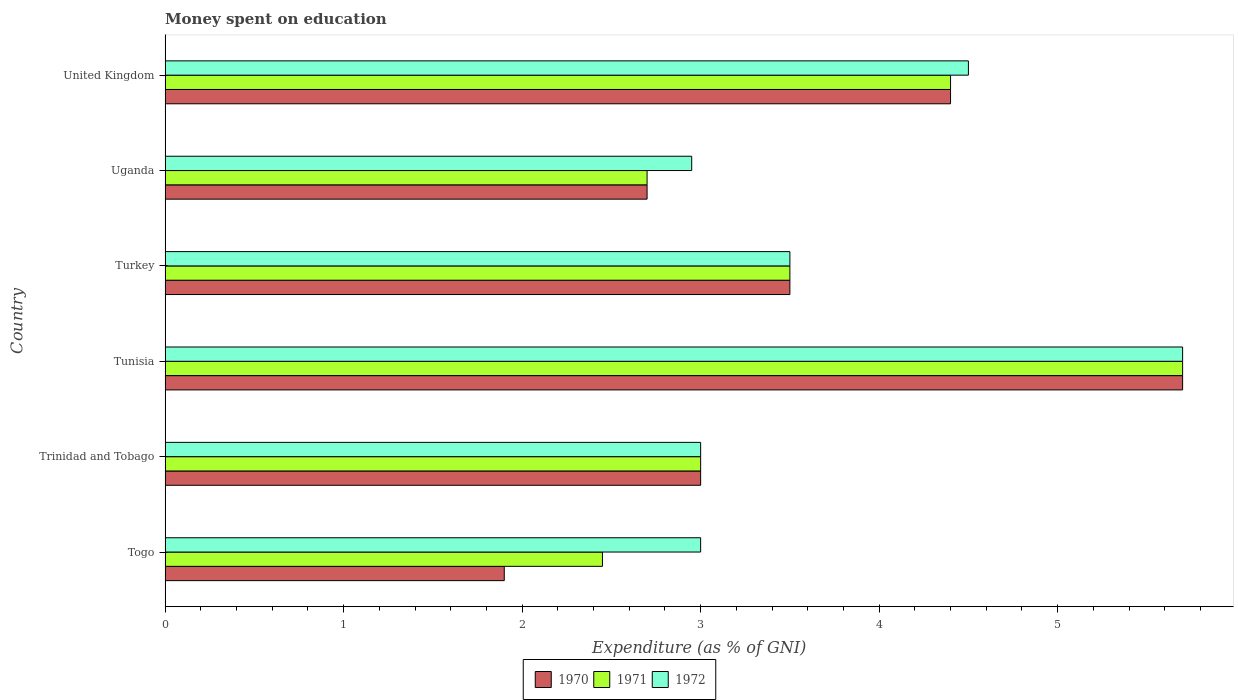How many groups of bars are there?
Offer a terse response. 6. Are the number of bars on each tick of the Y-axis equal?
Offer a terse response. Yes. What is the amount of money spent on education in 1972 in Turkey?
Ensure brevity in your answer.  3.5. Across all countries, what is the minimum amount of money spent on education in 1970?
Give a very brief answer. 1.9. In which country was the amount of money spent on education in 1972 maximum?
Offer a terse response. Tunisia. In which country was the amount of money spent on education in 1970 minimum?
Your answer should be very brief. Togo. What is the total amount of money spent on education in 1971 in the graph?
Your response must be concise. 21.75. What is the difference between the amount of money spent on education in 1971 in Togo and that in Uganda?
Keep it short and to the point. -0.25. What is the difference between the amount of money spent on education in 1970 in Togo and the amount of money spent on education in 1972 in Trinidad and Tobago?
Keep it short and to the point. -1.1. What is the average amount of money spent on education in 1970 per country?
Make the answer very short. 3.53. What is the difference between the amount of money spent on education in 1972 and amount of money spent on education in 1970 in Trinidad and Tobago?
Make the answer very short. 0. In how many countries, is the amount of money spent on education in 1971 greater than 2.4 %?
Provide a short and direct response. 6. What is the ratio of the amount of money spent on education in 1970 in Turkey to that in Uganda?
Provide a succinct answer. 1.3. Is the difference between the amount of money spent on education in 1972 in Tunisia and Turkey greater than the difference between the amount of money spent on education in 1970 in Tunisia and Turkey?
Offer a very short reply. No. What is the difference between the highest and the second highest amount of money spent on education in 1972?
Give a very brief answer. 1.2. What is the difference between the highest and the lowest amount of money spent on education in 1970?
Your response must be concise. 3.8. Is the sum of the amount of money spent on education in 1972 in Togo and United Kingdom greater than the maximum amount of money spent on education in 1971 across all countries?
Offer a terse response. Yes. What does the 3rd bar from the top in Tunisia represents?
Provide a short and direct response. 1970. Are all the bars in the graph horizontal?
Provide a short and direct response. Yes. How many countries are there in the graph?
Provide a short and direct response. 6. Are the values on the major ticks of X-axis written in scientific E-notation?
Your answer should be compact. No. Does the graph contain grids?
Your answer should be compact. No. Where does the legend appear in the graph?
Offer a very short reply. Bottom center. How are the legend labels stacked?
Ensure brevity in your answer.  Horizontal. What is the title of the graph?
Your answer should be very brief. Money spent on education. What is the label or title of the X-axis?
Your response must be concise. Expenditure (as % of GNI). What is the Expenditure (as % of GNI) in 1970 in Togo?
Provide a short and direct response. 1.9. What is the Expenditure (as % of GNI) in 1971 in Togo?
Make the answer very short. 2.45. What is the Expenditure (as % of GNI) of 1972 in Togo?
Provide a succinct answer. 3. What is the Expenditure (as % of GNI) of 1970 in Trinidad and Tobago?
Your response must be concise. 3. What is the Expenditure (as % of GNI) in 1971 in Trinidad and Tobago?
Give a very brief answer. 3. What is the Expenditure (as % of GNI) of 1970 in Tunisia?
Offer a terse response. 5.7. What is the Expenditure (as % of GNI) of 1970 in Turkey?
Provide a succinct answer. 3.5. What is the Expenditure (as % of GNI) in 1972 in Turkey?
Give a very brief answer. 3.5. What is the Expenditure (as % of GNI) in 1970 in Uganda?
Offer a very short reply. 2.7. What is the Expenditure (as % of GNI) in 1972 in Uganda?
Provide a succinct answer. 2.95. Across all countries, what is the maximum Expenditure (as % of GNI) in 1970?
Offer a terse response. 5.7. Across all countries, what is the maximum Expenditure (as % of GNI) of 1971?
Ensure brevity in your answer.  5.7. Across all countries, what is the maximum Expenditure (as % of GNI) of 1972?
Provide a succinct answer. 5.7. Across all countries, what is the minimum Expenditure (as % of GNI) of 1971?
Your response must be concise. 2.45. Across all countries, what is the minimum Expenditure (as % of GNI) of 1972?
Ensure brevity in your answer.  2.95. What is the total Expenditure (as % of GNI) in 1970 in the graph?
Make the answer very short. 21.2. What is the total Expenditure (as % of GNI) of 1971 in the graph?
Your answer should be compact. 21.75. What is the total Expenditure (as % of GNI) of 1972 in the graph?
Provide a short and direct response. 22.65. What is the difference between the Expenditure (as % of GNI) of 1970 in Togo and that in Trinidad and Tobago?
Give a very brief answer. -1.1. What is the difference between the Expenditure (as % of GNI) in 1971 in Togo and that in Trinidad and Tobago?
Make the answer very short. -0.55. What is the difference between the Expenditure (as % of GNI) in 1972 in Togo and that in Trinidad and Tobago?
Provide a succinct answer. 0. What is the difference between the Expenditure (as % of GNI) of 1970 in Togo and that in Tunisia?
Provide a short and direct response. -3.8. What is the difference between the Expenditure (as % of GNI) in 1971 in Togo and that in Tunisia?
Provide a short and direct response. -3.25. What is the difference between the Expenditure (as % of GNI) in 1972 in Togo and that in Tunisia?
Make the answer very short. -2.7. What is the difference between the Expenditure (as % of GNI) in 1970 in Togo and that in Turkey?
Your answer should be very brief. -1.6. What is the difference between the Expenditure (as % of GNI) of 1971 in Togo and that in Turkey?
Offer a very short reply. -1.05. What is the difference between the Expenditure (as % of GNI) in 1972 in Togo and that in Turkey?
Your answer should be compact. -0.5. What is the difference between the Expenditure (as % of GNI) in 1970 in Togo and that in Uganda?
Your answer should be compact. -0.8. What is the difference between the Expenditure (as % of GNI) in 1971 in Togo and that in Uganda?
Ensure brevity in your answer.  -0.25. What is the difference between the Expenditure (as % of GNI) in 1971 in Togo and that in United Kingdom?
Keep it short and to the point. -1.95. What is the difference between the Expenditure (as % of GNI) of 1971 in Trinidad and Tobago and that in Tunisia?
Keep it short and to the point. -2.7. What is the difference between the Expenditure (as % of GNI) of 1972 in Trinidad and Tobago and that in Tunisia?
Provide a short and direct response. -2.7. What is the difference between the Expenditure (as % of GNI) of 1972 in Trinidad and Tobago and that in Uganda?
Your answer should be compact. 0.05. What is the difference between the Expenditure (as % of GNI) of 1970 in Trinidad and Tobago and that in United Kingdom?
Offer a very short reply. -1.4. What is the difference between the Expenditure (as % of GNI) of 1971 in Trinidad and Tobago and that in United Kingdom?
Offer a terse response. -1.4. What is the difference between the Expenditure (as % of GNI) of 1972 in Trinidad and Tobago and that in United Kingdom?
Your answer should be compact. -1.5. What is the difference between the Expenditure (as % of GNI) in 1970 in Tunisia and that in Turkey?
Offer a very short reply. 2.2. What is the difference between the Expenditure (as % of GNI) of 1971 in Tunisia and that in Uganda?
Give a very brief answer. 3. What is the difference between the Expenditure (as % of GNI) of 1972 in Tunisia and that in Uganda?
Your response must be concise. 2.75. What is the difference between the Expenditure (as % of GNI) in 1971 in Tunisia and that in United Kingdom?
Make the answer very short. 1.3. What is the difference between the Expenditure (as % of GNI) in 1972 in Tunisia and that in United Kingdom?
Provide a short and direct response. 1.2. What is the difference between the Expenditure (as % of GNI) of 1970 in Turkey and that in Uganda?
Provide a short and direct response. 0.8. What is the difference between the Expenditure (as % of GNI) of 1972 in Turkey and that in Uganda?
Your answer should be very brief. 0.55. What is the difference between the Expenditure (as % of GNI) in 1970 in Turkey and that in United Kingdom?
Your answer should be very brief. -0.9. What is the difference between the Expenditure (as % of GNI) in 1971 in Turkey and that in United Kingdom?
Keep it short and to the point. -0.9. What is the difference between the Expenditure (as % of GNI) of 1972 in Turkey and that in United Kingdom?
Make the answer very short. -1. What is the difference between the Expenditure (as % of GNI) in 1972 in Uganda and that in United Kingdom?
Keep it short and to the point. -1.55. What is the difference between the Expenditure (as % of GNI) in 1970 in Togo and the Expenditure (as % of GNI) in 1971 in Trinidad and Tobago?
Your response must be concise. -1.1. What is the difference between the Expenditure (as % of GNI) of 1971 in Togo and the Expenditure (as % of GNI) of 1972 in Trinidad and Tobago?
Offer a very short reply. -0.55. What is the difference between the Expenditure (as % of GNI) of 1970 in Togo and the Expenditure (as % of GNI) of 1971 in Tunisia?
Provide a succinct answer. -3.8. What is the difference between the Expenditure (as % of GNI) of 1970 in Togo and the Expenditure (as % of GNI) of 1972 in Tunisia?
Your answer should be very brief. -3.8. What is the difference between the Expenditure (as % of GNI) in 1971 in Togo and the Expenditure (as % of GNI) in 1972 in Tunisia?
Offer a very short reply. -3.25. What is the difference between the Expenditure (as % of GNI) in 1970 in Togo and the Expenditure (as % of GNI) in 1971 in Turkey?
Your answer should be very brief. -1.6. What is the difference between the Expenditure (as % of GNI) of 1970 in Togo and the Expenditure (as % of GNI) of 1972 in Turkey?
Make the answer very short. -1.6. What is the difference between the Expenditure (as % of GNI) in 1971 in Togo and the Expenditure (as % of GNI) in 1972 in Turkey?
Make the answer very short. -1.05. What is the difference between the Expenditure (as % of GNI) in 1970 in Togo and the Expenditure (as % of GNI) in 1971 in Uganda?
Your answer should be very brief. -0.8. What is the difference between the Expenditure (as % of GNI) in 1970 in Togo and the Expenditure (as % of GNI) in 1972 in Uganda?
Keep it short and to the point. -1.05. What is the difference between the Expenditure (as % of GNI) of 1971 in Togo and the Expenditure (as % of GNI) of 1972 in United Kingdom?
Offer a terse response. -2.05. What is the difference between the Expenditure (as % of GNI) of 1970 in Trinidad and Tobago and the Expenditure (as % of GNI) of 1972 in Tunisia?
Give a very brief answer. -2.7. What is the difference between the Expenditure (as % of GNI) in 1971 in Trinidad and Tobago and the Expenditure (as % of GNI) in 1972 in Tunisia?
Offer a terse response. -2.7. What is the difference between the Expenditure (as % of GNI) in 1970 in Trinidad and Tobago and the Expenditure (as % of GNI) in 1971 in Turkey?
Your response must be concise. -0.5. What is the difference between the Expenditure (as % of GNI) in 1970 in Trinidad and Tobago and the Expenditure (as % of GNI) in 1972 in Turkey?
Your answer should be compact. -0.5. What is the difference between the Expenditure (as % of GNI) of 1970 in Trinidad and Tobago and the Expenditure (as % of GNI) of 1971 in United Kingdom?
Your answer should be very brief. -1.4. What is the difference between the Expenditure (as % of GNI) of 1970 in Trinidad and Tobago and the Expenditure (as % of GNI) of 1972 in United Kingdom?
Ensure brevity in your answer.  -1.5. What is the difference between the Expenditure (as % of GNI) in 1971 in Trinidad and Tobago and the Expenditure (as % of GNI) in 1972 in United Kingdom?
Keep it short and to the point. -1.5. What is the difference between the Expenditure (as % of GNI) in 1970 in Tunisia and the Expenditure (as % of GNI) in 1972 in Turkey?
Make the answer very short. 2.2. What is the difference between the Expenditure (as % of GNI) of 1971 in Tunisia and the Expenditure (as % of GNI) of 1972 in Turkey?
Provide a succinct answer. 2.2. What is the difference between the Expenditure (as % of GNI) of 1970 in Tunisia and the Expenditure (as % of GNI) of 1971 in Uganda?
Provide a succinct answer. 3. What is the difference between the Expenditure (as % of GNI) in 1970 in Tunisia and the Expenditure (as % of GNI) in 1972 in Uganda?
Your answer should be very brief. 2.75. What is the difference between the Expenditure (as % of GNI) of 1971 in Tunisia and the Expenditure (as % of GNI) of 1972 in Uganda?
Make the answer very short. 2.75. What is the difference between the Expenditure (as % of GNI) in 1970 in Tunisia and the Expenditure (as % of GNI) in 1971 in United Kingdom?
Give a very brief answer. 1.3. What is the difference between the Expenditure (as % of GNI) in 1970 in Turkey and the Expenditure (as % of GNI) in 1972 in Uganda?
Offer a terse response. 0.55. What is the difference between the Expenditure (as % of GNI) of 1971 in Turkey and the Expenditure (as % of GNI) of 1972 in Uganda?
Ensure brevity in your answer.  0.55. What is the difference between the Expenditure (as % of GNI) of 1970 in Turkey and the Expenditure (as % of GNI) of 1972 in United Kingdom?
Your answer should be very brief. -1. What is the difference between the Expenditure (as % of GNI) in 1971 in Turkey and the Expenditure (as % of GNI) in 1972 in United Kingdom?
Ensure brevity in your answer.  -1. What is the average Expenditure (as % of GNI) in 1970 per country?
Offer a terse response. 3.53. What is the average Expenditure (as % of GNI) in 1971 per country?
Provide a short and direct response. 3.62. What is the average Expenditure (as % of GNI) in 1972 per country?
Keep it short and to the point. 3.77. What is the difference between the Expenditure (as % of GNI) in 1970 and Expenditure (as % of GNI) in 1971 in Togo?
Offer a terse response. -0.55. What is the difference between the Expenditure (as % of GNI) in 1970 and Expenditure (as % of GNI) in 1972 in Togo?
Make the answer very short. -1.1. What is the difference between the Expenditure (as % of GNI) of 1971 and Expenditure (as % of GNI) of 1972 in Togo?
Your response must be concise. -0.55. What is the difference between the Expenditure (as % of GNI) of 1970 and Expenditure (as % of GNI) of 1971 in Trinidad and Tobago?
Your answer should be very brief. 0. What is the difference between the Expenditure (as % of GNI) in 1971 and Expenditure (as % of GNI) in 1972 in Trinidad and Tobago?
Your answer should be very brief. 0. What is the difference between the Expenditure (as % of GNI) in 1970 and Expenditure (as % of GNI) in 1971 in Uganda?
Ensure brevity in your answer.  0. What is the difference between the Expenditure (as % of GNI) of 1970 and Expenditure (as % of GNI) of 1971 in United Kingdom?
Your response must be concise. 0. What is the difference between the Expenditure (as % of GNI) in 1970 and Expenditure (as % of GNI) in 1972 in United Kingdom?
Your response must be concise. -0.1. What is the ratio of the Expenditure (as % of GNI) of 1970 in Togo to that in Trinidad and Tobago?
Ensure brevity in your answer.  0.63. What is the ratio of the Expenditure (as % of GNI) of 1971 in Togo to that in Trinidad and Tobago?
Your answer should be compact. 0.82. What is the ratio of the Expenditure (as % of GNI) of 1972 in Togo to that in Trinidad and Tobago?
Make the answer very short. 1. What is the ratio of the Expenditure (as % of GNI) of 1970 in Togo to that in Tunisia?
Offer a very short reply. 0.33. What is the ratio of the Expenditure (as % of GNI) in 1971 in Togo to that in Tunisia?
Your response must be concise. 0.43. What is the ratio of the Expenditure (as % of GNI) in 1972 in Togo to that in Tunisia?
Give a very brief answer. 0.53. What is the ratio of the Expenditure (as % of GNI) in 1970 in Togo to that in Turkey?
Offer a very short reply. 0.54. What is the ratio of the Expenditure (as % of GNI) in 1971 in Togo to that in Turkey?
Offer a very short reply. 0.7. What is the ratio of the Expenditure (as % of GNI) of 1970 in Togo to that in Uganda?
Your answer should be compact. 0.7. What is the ratio of the Expenditure (as % of GNI) of 1971 in Togo to that in Uganda?
Your response must be concise. 0.91. What is the ratio of the Expenditure (as % of GNI) in 1972 in Togo to that in Uganda?
Ensure brevity in your answer.  1.02. What is the ratio of the Expenditure (as % of GNI) of 1970 in Togo to that in United Kingdom?
Provide a short and direct response. 0.43. What is the ratio of the Expenditure (as % of GNI) of 1971 in Togo to that in United Kingdom?
Offer a terse response. 0.56. What is the ratio of the Expenditure (as % of GNI) in 1970 in Trinidad and Tobago to that in Tunisia?
Provide a succinct answer. 0.53. What is the ratio of the Expenditure (as % of GNI) of 1971 in Trinidad and Tobago to that in Tunisia?
Give a very brief answer. 0.53. What is the ratio of the Expenditure (as % of GNI) in 1972 in Trinidad and Tobago to that in Tunisia?
Give a very brief answer. 0.53. What is the ratio of the Expenditure (as % of GNI) of 1970 in Trinidad and Tobago to that in Uganda?
Your response must be concise. 1.11. What is the ratio of the Expenditure (as % of GNI) of 1972 in Trinidad and Tobago to that in Uganda?
Offer a terse response. 1.02. What is the ratio of the Expenditure (as % of GNI) of 1970 in Trinidad and Tobago to that in United Kingdom?
Offer a terse response. 0.68. What is the ratio of the Expenditure (as % of GNI) of 1971 in Trinidad and Tobago to that in United Kingdom?
Your response must be concise. 0.68. What is the ratio of the Expenditure (as % of GNI) of 1970 in Tunisia to that in Turkey?
Make the answer very short. 1.63. What is the ratio of the Expenditure (as % of GNI) of 1971 in Tunisia to that in Turkey?
Provide a short and direct response. 1.63. What is the ratio of the Expenditure (as % of GNI) in 1972 in Tunisia to that in Turkey?
Offer a terse response. 1.63. What is the ratio of the Expenditure (as % of GNI) of 1970 in Tunisia to that in Uganda?
Give a very brief answer. 2.11. What is the ratio of the Expenditure (as % of GNI) in 1971 in Tunisia to that in Uganda?
Keep it short and to the point. 2.11. What is the ratio of the Expenditure (as % of GNI) in 1972 in Tunisia to that in Uganda?
Your response must be concise. 1.93. What is the ratio of the Expenditure (as % of GNI) in 1970 in Tunisia to that in United Kingdom?
Provide a succinct answer. 1.3. What is the ratio of the Expenditure (as % of GNI) of 1971 in Tunisia to that in United Kingdom?
Your answer should be compact. 1.3. What is the ratio of the Expenditure (as % of GNI) of 1972 in Tunisia to that in United Kingdom?
Provide a short and direct response. 1.27. What is the ratio of the Expenditure (as % of GNI) of 1970 in Turkey to that in Uganda?
Make the answer very short. 1.3. What is the ratio of the Expenditure (as % of GNI) in 1971 in Turkey to that in Uganda?
Keep it short and to the point. 1.3. What is the ratio of the Expenditure (as % of GNI) in 1972 in Turkey to that in Uganda?
Make the answer very short. 1.19. What is the ratio of the Expenditure (as % of GNI) in 1970 in Turkey to that in United Kingdom?
Offer a very short reply. 0.8. What is the ratio of the Expenditure (as % of GNI) in 1971 in Turkey to that in United Kingdom?
Offer a terse response. 0.8. What is the ratio of the Expenditure (as % of GNI) in 1972 in Turkey to that in United Kingdom?
Provide a succinct answer. 0.78. What is the ratio of the Expenditure (as % of GNI) of 1970 in Uganda to that in United Kingdom?
Offer a very short reply. 0.61. What is the ratio of the Expenditure (as % of GNI) of 1971 in Uganda to that in United Kingdom?
Ensure brevity in your answer.  0.61. What is the ratio of the Expenditure (as % of GNI) in 1972 in Uganda to that in United Kingdom?
Provide a short and direct response. 0.66. What is the difference between the highest and the second highest Expenditure (as % of GNI) in 1971?
Make the answer very short. 1.3. What is the difference between the highest and the lowest Expenditure (as % of GNI) of 1970?
Ensure brevity in your answer.  3.8. What is the difference between the highest and the lowest Expenditure (as % of GNI) of 1971?
Your answer should be compact. 3.25. What is the difference between the highest and the lowest Expenditure (as % of GNI) in 1972?
Offer a very short reply. 2.75. 